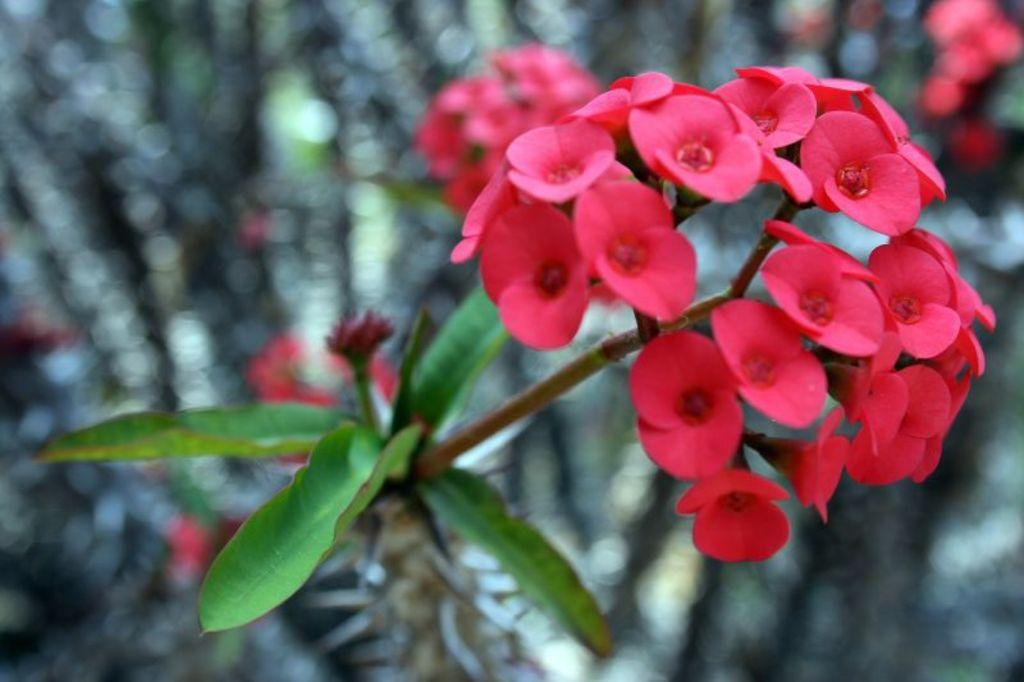What type of flowers are present in the image? There are pink flowers in the image. What else can be seen connected to the flowers? There are stems in the image. What color are the leaves in the image? There are green leaves in the image. What type of land can be seen in the image? There is no land visible in the image; it features pink flowers, stems, and green leaves. What grade of flowers are shown in the image? The image does not provide information about the grade of the flowers; it only shows their color and appearance. 